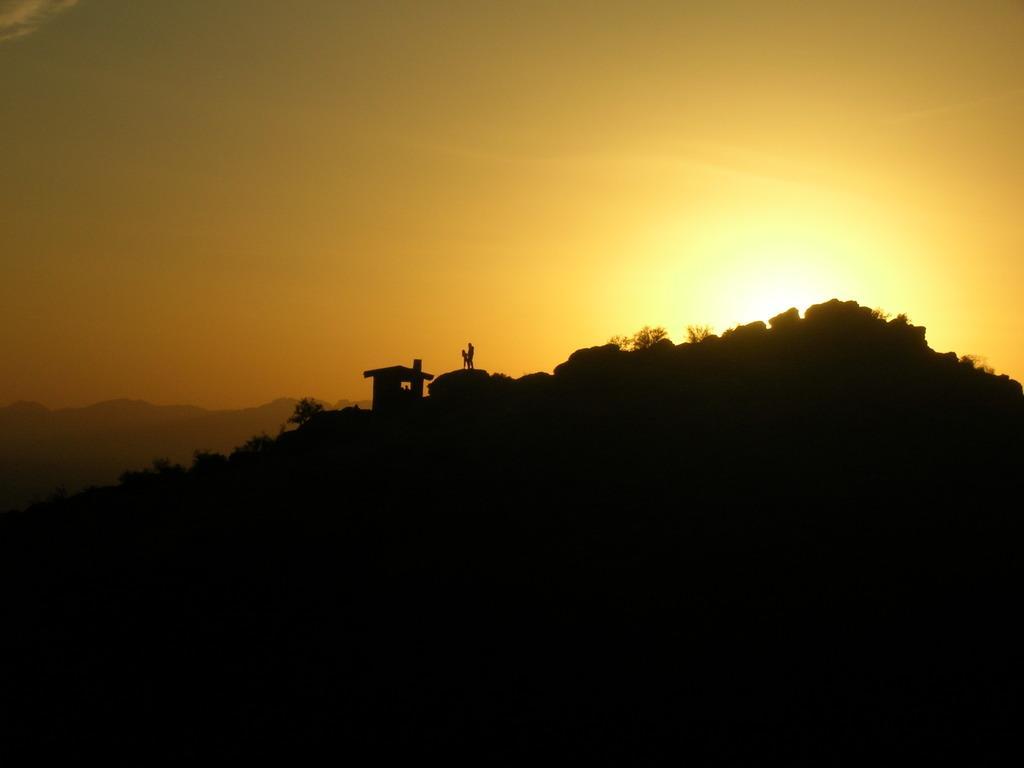How would you summarize this image in a sentence or two? In this image we can see persons and house on a hill. In the background there is a sky and a hill. 